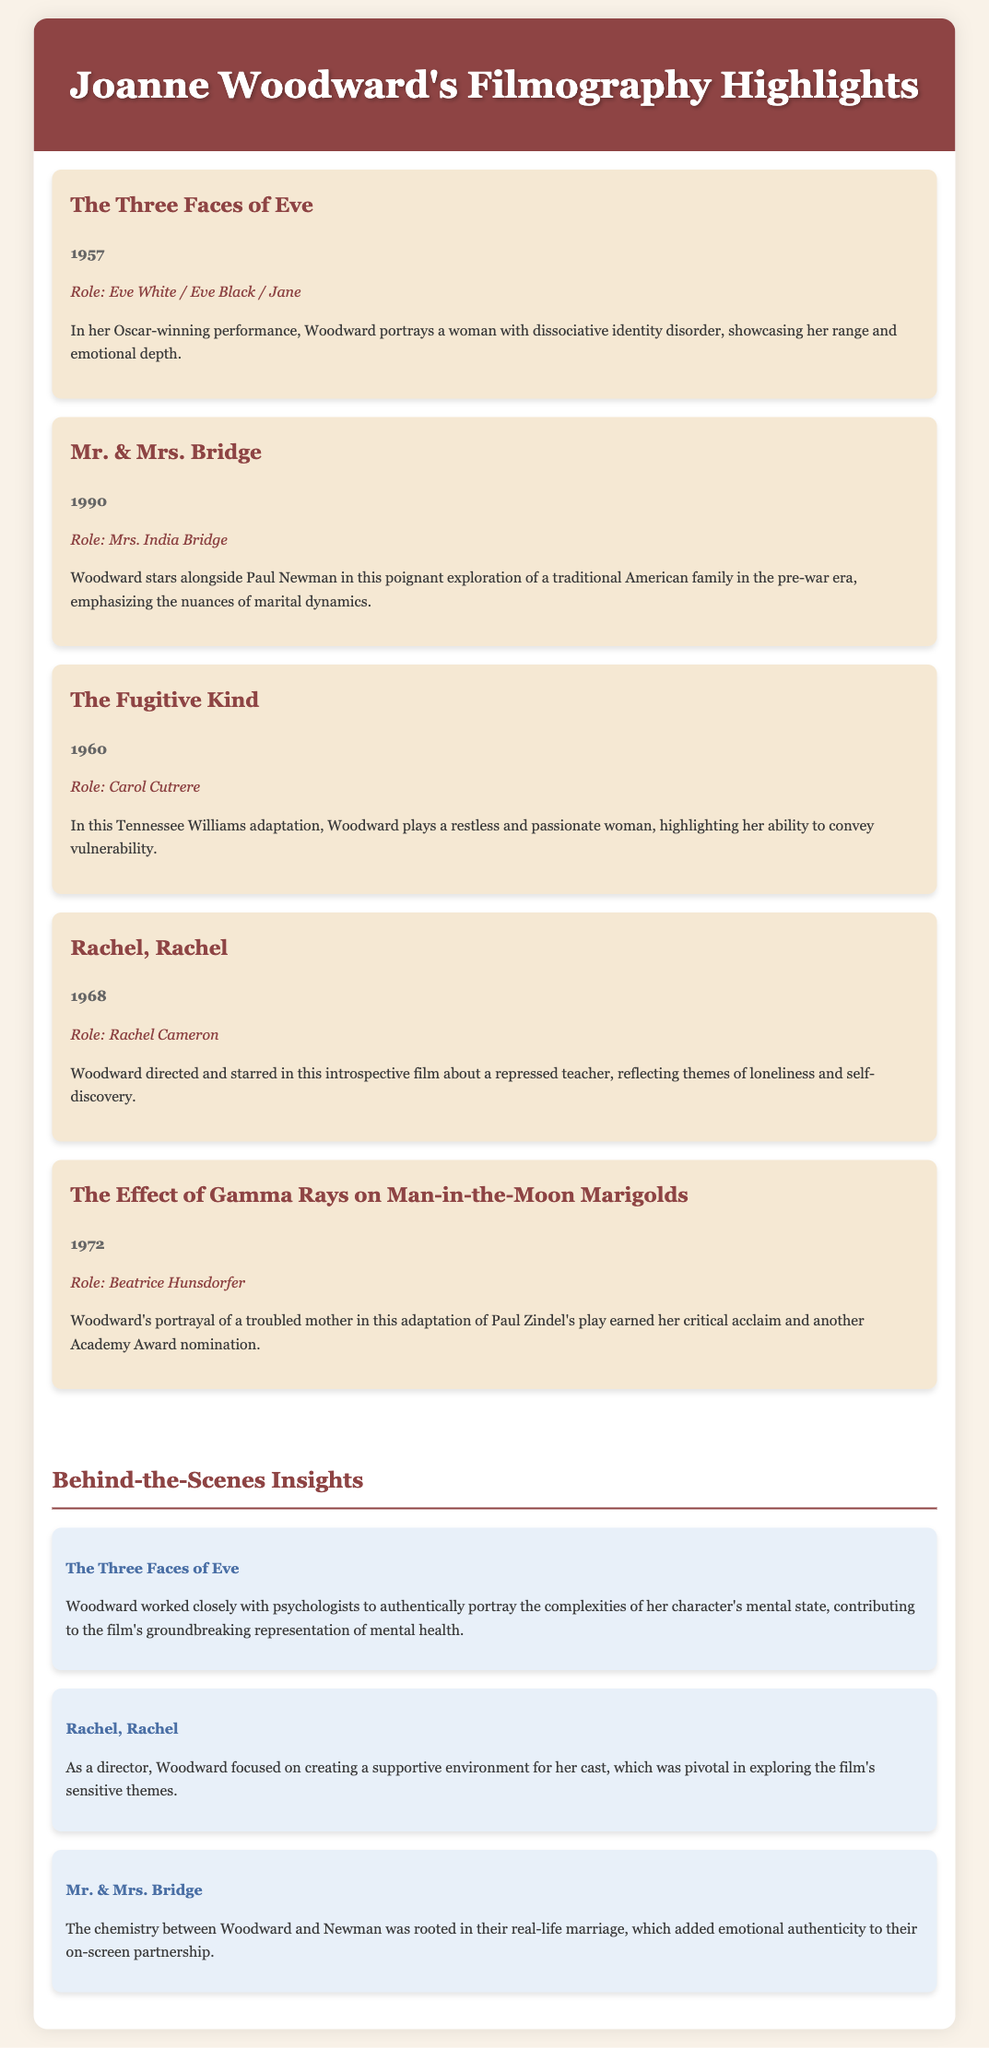What is the title of Joanne Woodward's Oscar-winning performance? The title of her Oscar-winning performance is "The Three Faces of Eve," where she portrays a woman with dissociative identity disorder.
Answer: The Three Faces of Eve In which year was "Mr. & Mrs. Bridge" released? "Mr. & Mrs. Bridge" was released in 1990, as indicated in the filmography highlights.
Answer: 1990 What role did Joanne Woodward play in "The Fugitive Kind"? In "The Fugitive Kind," she played the role of Carol Cutrere, showcasing her emotional range.
Answer: Carol Cutrere How many Academy Award nominations did Woodward receive for "The Effect of Gamma Rays on Man-in-the-Moon Marigolds"? Woodward earned an Academy Award nomination for her role in this film, though the document does not specify the total count of nominations she received.
Answer: One What unique aspect did Woodward bring to directing "Rachel, Rachel"? Woodward focused on creating a supportive environment for the cast, which was key in tackling sensitive themes in the film.
Answer: Supportive environment What is highlighted about the chemistry between Woodward and Newman in "Mr. & Mrs. Bridge"? Their chemistry stems from their real-life marriage, which added emotional authenticity to their partnership on-screen.
Answer: Real-life marriage What is the common theme among the films highlighted in Woodward's filmography? The films explore deep emotional themes and showcase Woodward’s range as an actress, reflecting personal struggles and relationships.
Answer: Emotional themes 